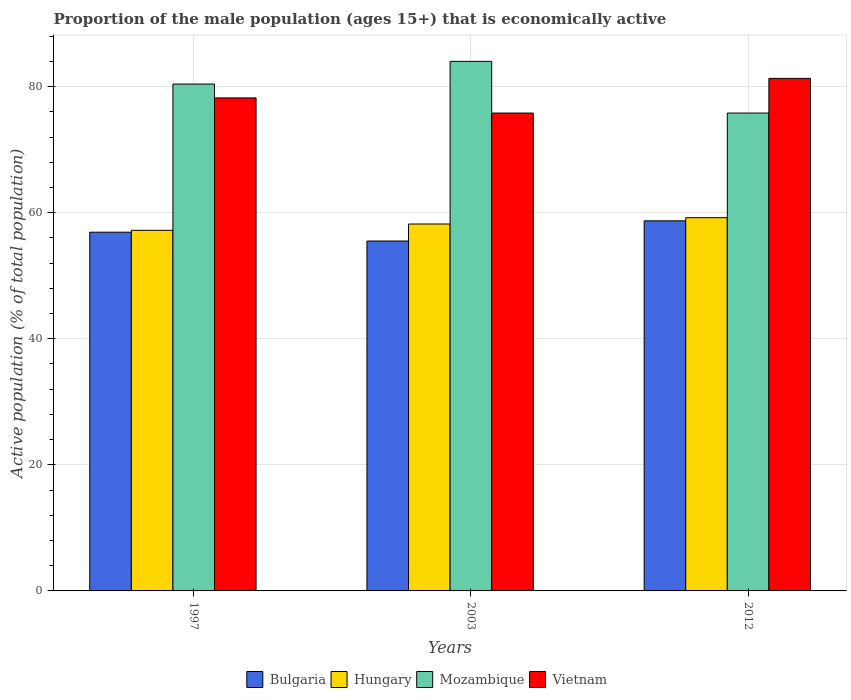How many bars are there on the 3rd tick from the left?
Keep it short and to the point. 4. What is the proportion of the male population that is economically active in Bulgaria in 2012?
Provide a succinct answer. 58.7. Across all years, what is the maximum proportion of the male population that is economically active in Hungary?
Your response must be concise. 59.2. Across all years, what is the minimum proportion of the male population that is economically active in Vietnam?
Your answer should be very brief. 75.8. In which year was the proportion of the male population that is economically active in Mozambique maximum?
Give a very brief answer. 2003. In which year was the proportion of the male population that is economically active in Mozambique minimum?
Give a very brief answer. 2012. What is the total proportion of the male population that is economically active in Bulgaria in the graph?
Your answer should be compact. 171.1. What is the difference between the proportion of the male population that is economically active in Bulgaria in 1997 and that in 2003?
Ensure brevity in your answer.  1.4. What is the difference between the proportion of the male population that is economically active in Vietnam in 1997 and the proportion of the male population that is economically active in Mozambique in 2012?
Your answer should be very brief. 2.4. What is the average proportion of the male population that is economically active in Bulgaria per year?
Your answer should be very brief. 57.03. In the year 1997, what is the difference between the proportion of the male population that is economically active in Vietnam and proportion of the male population that is economically active in Bulgaria?
Keep it short and to the point. 21.3. What is the ratio of the proportion of the male population that is economically active in Mozambique in 1997 to that in 2012?
Provide a succinct answer. 1.06. What is the difference between the highest and the second highest proportion of the male population that is economically active in Bulgaria?
Ensure brevity in your answer.  1.8. What is the difference between the highest and the lowest proportion of the male population that is economically active in Hungary?
Give a very brief answer. 2. Is the sum of the proportion of the male population that is economically active in Hungary in 1997 and 2012 greater than the maximum proportion of the male population that is economically active in Vietnam across all years?
Keep it short and to the point. Yes. Is it the case that in every year, the sum of the proportion of the male population that is economically active in Vietnam and proportion of the male population that is economically active in Bulgaria is greater than the sum of proportion of the male population that is economically active in Hungary and proportion of the male population that is economically active in Mozambique?
Your response must be concise. Yes. What does the 4th bar from the left in 1997 represents?
Make the answer very short. Vietnam. What does the 3rd bar from the right in 2003 represents?
Your response must be concise. Hungary. Is it the case that in every year, the sum of the proportion of the male population that is economically active in Bulgaria and proportion of the male population that is economically active in Hungary is greater than the proportion of the male population that is economically active in Mozambique?
Your response must be concise. Yes. How many bars are there?
Provide a succinct answer. 12. How many years are there in the graph?
Make the answer very short. 3. Does the graph contain any zero values?
Provide a succinct answer. No. Where does the legend appear in the graph?
Keep it short and to the point. Bottom center. How many legend labels are there?
Your answer should be very brief. 4. What is the title of the graph?
Make the answer very short. Proportion of the male population (ages 15+) that is economically active. What is the label or title of the Y-axis?
Keep it short and to the point. Active population (% of total population). What is the Active population (% of total population) in Bulgaria in 1997?
Give a very brief answer. 56.9. What is the Active population (% of total population) of Hungary in 1997?
Provide a short and direct response. 57.2. What is the Active population (% of total population) in Mozambique in 1997?
Keep it short and to the point. 80.4. What is the Active population (% of total population) of Vietnam in 1997?
Offer a very short reply. 78.2. What is the Active population (% of total population) in Bulgaria in 2003?
Provide a succinct answer. 55.5. What is the Active population (% of total population) in Hungary in 2003?
Offer a terse response. 58.2. What is the Active population (% of total population) of Mozambique in 2003?
Your answer should be very brief. 84. What is the Active population (% of total population) of Vietnam in 2003?
Provide a succinct answer. 75.8. What is the Active population (% of total population) in Bulgaria in 2012?
Your answer should be compact. 58.7. What is the Active population (% of total population) in Hungary in 2012?
Give a very brief answer. 59.2. What is the Active population (% of total population) in Mozambique in 2012?
Ensure brevity in your answer.  75.8. What is the Active population (% of total population) of Vietnam in 2012?
Your answer should be compact. 81.3. Across all years, what is the maximum Active population (% of total population) of Bulgaria?
Make the answer very short. 58.7. Across all years, what is the maximum Active population (% of total population) in Hungary?
Your response must be concise. 59.2. Across all years, what is the maximum Active population (% of total population) of Mozambique?
Give a very brief answer. 84. Across all years, what is the maximum Active population (% of total population) in Vietnam?
Offer a very short reply. 81.3. Across all years, what is the minimum Active population (% of total population) of Bulgaria?
Offer a very short reply. 55.5. Across all years, what is the minimum Active population (% of total population) in Hungary?
Offer a terse response. 57.2. Across all years, what is the minimum Active population (% of total population) in Mozambique?
Your answer should be compact. 75.8. Across all years, what is the minimum Active population (% of total population) in Vietnam?
Provide a succinct answer. 75.8. What is the total Active population (% of total population) in Bulgaria in the graph?
Offer a very short reply. 171.1. What is the total Active population (% of total population) of Hungary in the graph?
Your response must be concise. 174.6. What is the total Active population (% of total population) in Mozambique in the graph?
Make the answer very short. 240.2. What is the total Active population (% of total population) of Vietnam in the graph?
Your response must be concise. 235.3. What is the difference between the Active population (% of total population) in Mozambique in 1997 and that in 2003?
Offer a terse response. -3.6. What is the difference between the Active population (% of total population) in Vietnam in 1997 and that in 2003?
Your answer should be compact. 2.4. What is the difference between the Active population (% of total population) of Bulgaria in 1997 and that in 2012?
Ensure brevity in your answer.  -1.8. What is the difference between the Active population (% of total population) of Hungary in 1997 and that in 2012?
Offer a terse response. -2. What is the difference between the Active population (% of total population) in Mozambique in 1997 and that in 2012?
Give a very brief answer. 4.6. What is the difference between the Active population (% of total population) of Bulgaria in 2003 and that in 2012?
Ensure brevity in your answer.  -3.2. What is the difference between the Active population (% of total population) of Hungary in 2003 and that in 2012?
Offer a terse response. -1. What is the difference between the Active population (% of total population) in Mozambique in 2003 and that in 2012?
Keep it short and to the point. 8.2. What is the difference between the Active population (% of total population) of Bulgaria in 1997 and the Active population (% of total population) of Mozambique in 2003?
Make the answer very short. -27.1. What is the difference between the Active population (% of total population) in Bulgaria in 1997 and the Active population (% of total population) in Vietnam in 2003?
Ensure brevity in your answer.  -18.9. What is the difference between the Active population (% of total population) of Hungary in 1997 and the Active population (% of total population) of Mozambique in 2003?
Provide a succinct answer. -26.8. What is the difference between the Active population (% of total population) of Hungary in 1997 and the Active population (% of total population) of Vietnam in 2003?
Provide a short and direct response. -18.6. What is the difference between the Active population (% of total population) in Bulgaria in 1997 and the Active population (% of total population) in Hungary in 2012?
Your response must be concise. -2.3. What is the difference between the Active population (% of total population) in Bulgaria in 1997 and the Active population (% of total population) in Mozambique in 2012?
Your answer should be compact. -18.9. What is the difference between the Active population (% of total population) of Bulgaria in 1997 and the Active population (% of total population) of Vietnam in 2012?
Keep it short and to the point. -24.4. What is the difference between the Active population (% of total population) of Hungary in 1997 and the Active population (% of total population) of Mozambique in 2012?
Offer a very short reply. -18.6. What is the difference between the Active population (% of total population) of Hungary in 1997 and the Active population (% of total population) of Vietnam in 2012?
Your answer should be compact. -24.1. What is the difference between the Active population (% of total population) in Mozambique in 1997 and the Active population (% of total population) in Vietnam in 2012?
Your answer should be very brief. -0.9. What is the difference between the Active population (% of total population) in Bulgaria in 2003 and the Active population (% of total population) in Mozambique in 2012?
Your answer should be very brief. -20.3. What is the difference between the Active population (% of total population) of Bulgaria in 2003 and the Active population (% of total population) of Vietnam in 2012?
Your answer should be very brief. -25.8. What is the difference between the Active population (% of total population) of Hungary in 2003 and the Active population (% of total population) of Mozambique in 2012?
Make the answer very short. -17.6. What is the difference between the Active population (% of total population) in Hungary in 2003 and the Active population (% of total population) in Vietnam in 2012?
Your answer should be very brief. -23.1. What is the average Active population (% of total population) in Bulgaria per year?
Provide a succinct answer. 57.03. What is the average Active population (% of total population) in Hungary per year?
Offer a very short reply. 58.2. What is the average Active population (% of total population) of Mozambique per year?
Your response must be concise. 80.07. What is the average Active population (% of total population) in Vietnam per year?
Your answer should be very brief. 78.43. In the year 1997, what is the difference between the Active population (% of total population) in Bulgaria and Active population (% of total population) in Hungary?
Keep it short and to the point. -0.3. In the year 1997, what is the difference between the Active population (% of total population) of Bulgaria and Active population (% of total population) of Mozambique?
Your response must be concise. -23.5. In the year 1997, what is the difference between the Active population (% of total population) in Bulgaria and Active population (% of total population) in Vietnam?
Your answer should be compact. -21.3. In the year 1997, what is the difference between the Active population (% of total population) of Hungary and Active population (% of total population) of Mozambique?
Your answer should be compact. -23.2. In the year 1997, what is the difference between the Active population (% of total population) in Mozambique and Active population (% of total population) in Vietnam?
Ensure brevity in your answer.  2.2. In the year 2003, what is the difference between the Active population (% of total population) in Bulgaria and Active population (% of total population) in Hungary?
Your answer should be very brief. -2.7. In the year 2003, what is the difference between the Active population (% of total population) of Bulgaria and Active population (% of total population) of Mozambique?
Ensure brevity in your answer.  -28.5. In the year 2003, what is the difference between the Active population (% of total population) of Bulgaria and Active population (% of total population) of Vietnam?
Provide a succinct answer. -20.3. In the year 2003, what is the difference between the Active population (% of total population) of Hungary and Active population (% of total population) of Mozambique?
Your answer should be very brief. -25.8. In the year 2003, what is the difference between the Active population (% of total population) of Hungary and Active population (% of total population) of Vietnam?
Your response must be concise. -17.6. In the year 2012, what is the difference between the Active population (% of total population) of Bulgaria and Active population (% of total population) of Mozambique?
Keep it short and to the point. -17.1. In the year 2012, what is the difference between the Active population (% of total population) in Bulgaria and Active population (% of total population) in Vietnam?
Provide a succinct answer. -22.6. In the year 2012, what is the difference between the Active population (% of total population) in Hungary and Active population (% of total population) in Mozambique?
Keep it short and to the point. -16.6. In the year 2012, what is the difference between the Active population (% of total population) in Hungary and Active population (% of total population) in Vietnam?
Make the answer very short. -22.1. What is the ratio of the Active population (% of total population) in Bulgaria in 1997 to that in 2003?
Offer a terse response. 1.03. What is the ratio of the Active population (% of total population) of Hungary in 1997 to that in 2003?
Offer a very short reply. 0.98. What is the ratio of the Active population (% of total population) of Mozambique in 1997 to that in 2003?
Offer a very short reply. 0.96. What is the ratio of the Active population (% of total population) of Vietnam in 1997 to that in 2003?
Make the answer very short. 1.03. What is the ratio of the Active population (% of total population) of Bulgaria in 1997 to that in 2012?
Offer a very short reply. 0.97. What is the ratio of the Active population (% of total population) of Hungary in 1997 to that in 2012?
Ensure brevity in your answer.  0.97. What is the ratio of the Active population (% of total population) in Mozambique in 1997 to that in 2012?
Provide a succinct answer. 1.06. What is the ratio of the Active population (% of total population) of Vietnam in 1997 to that in 2012?
Give a very brief answer. 0.96. What is the ratio of the Active population (% of total population) of Bulgaria in 2003 to that in 2012?
Ensure brevity in your answer.  0.95. What is the ratio of the Active population (% of total population) of Hungary in 2003 to that in 2012?
Your answer should be very brief. 0.98. What is the ratio of the Active population (% of total population) of Mozambique in 2003 to that in 2012?
Provide a succinct answer. 1.11. What is the ratio of the Active population (% of total population) of Vietnam in 2003 to that in 2012?
Provide a short and direct response. 0.93. What is the difference between the highest and the second highest Active population (% of total population) of Bulgaria?
Offer a terse response. 1.8. What is the difference between the highest and the second highest Active population (% of total population) of Hungary?
Ensure brevity in your answer.  1. What is the difference between the highest and the lowest Active population (% of total population) of Hungary?
Your answer should be very brief. 2. What is the difference between the highest and the lowest Active population (% of total population) in Mozambique?
Ensure brevity in your answer.  8.2. What is the difference between the highest and the lowest Active population (% of total population) of Vietnam?
Your answer should be very brief. 5.5. 